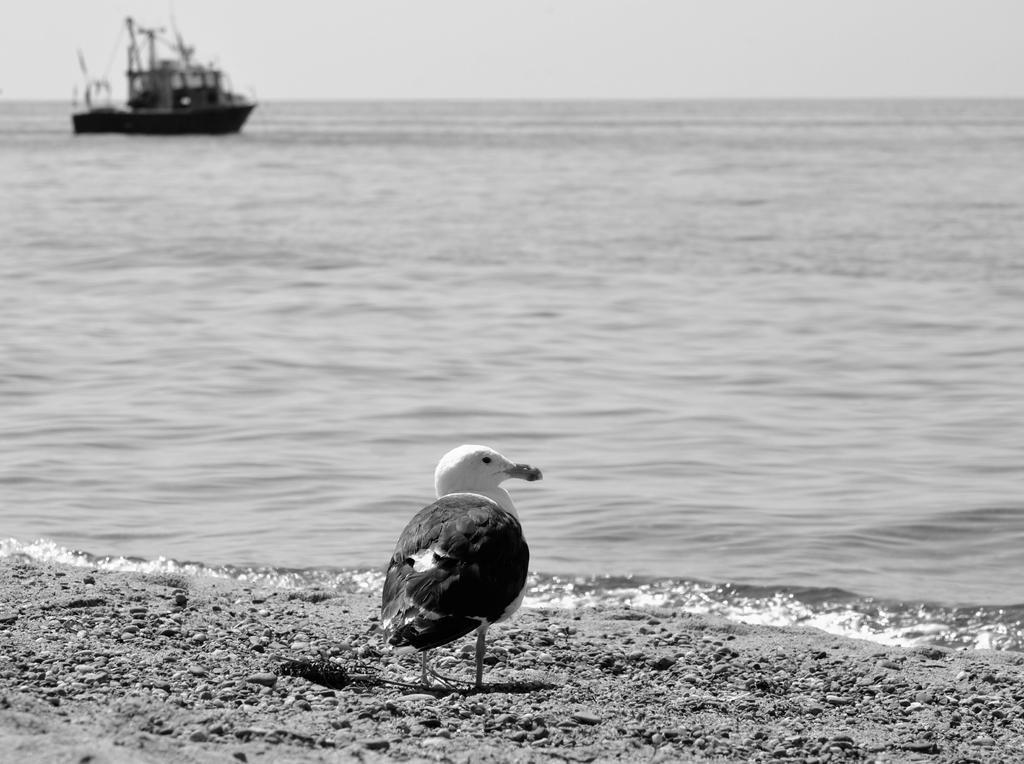What is the main subject in the foreground of the image? There is a bird in the foreground of the image. What type of terrain is visible at the bottom of the image? There is sand at the bottom of the image. What body of water is present in the image? There is a river in the center of the image. What is floating on the river? There is a ship in the river. How far is the knee from the bird in the image? There is no knee present in the image, as it features a bird, sand, a river, and a ship. 